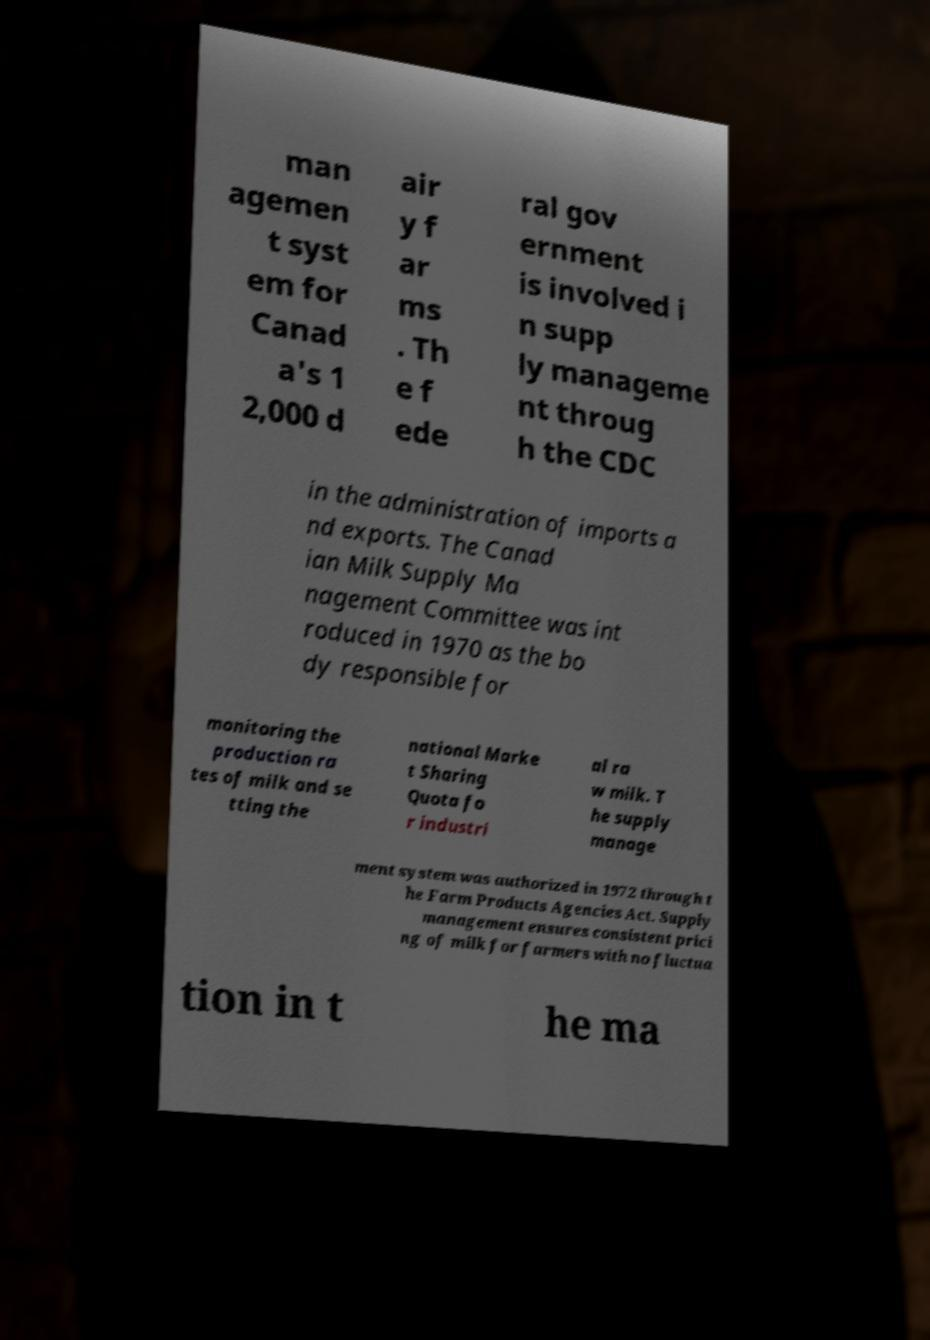I need the written content from this picture converted into text. Can you do that? man agemen t syst em for Canad a's 1 2,000 d air y f ar ms . Th e f ede ral gov ernment is involved i n supp ly manageme nt throug h the CDC in the administration of imports a nd exports. The Canad ian Milk Supply Ma nagement Committee was int roduced in 1970 as the bo dy responsible for monitoring the production ra tes of milk and se tting the national Marke t Sharing Quota fo r industri al ra w milk. T he supply manage ment system was authorized in 1972 through t he Farm Products Agencies Act. Supply management ensures consistent prici ng of milk for farmers with no fluctua tion in t he ma 